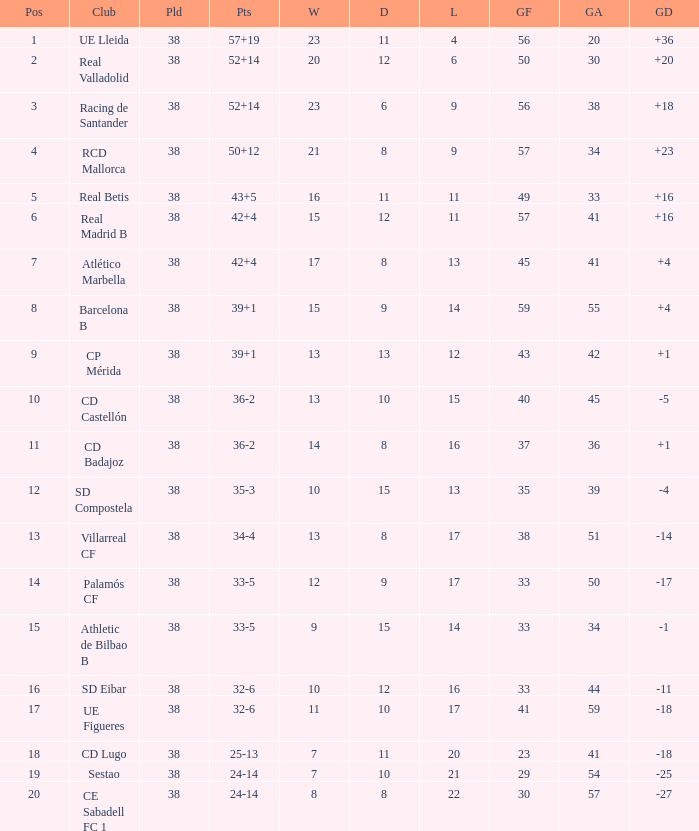What is the highest position with less than 17 losses, more than 57 goals, and a goal difference less than 4? None. 